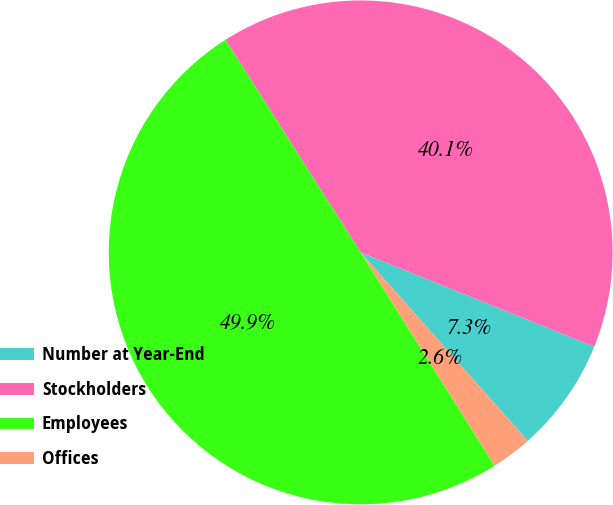Convert chart to OTSL. <chart><loc_0><loc_0><loc_500><loc_500><pie_chart><fcel>Number at Year-End<fcel>Stockholders<fcel>Employees<fcel>Offices<nl><fcel>7.35%<fcel>40.13%<fcel>49.9%<fcel>2.62%<nl></chart> 